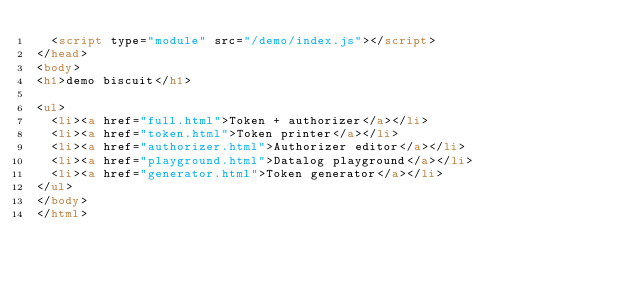Convert code to text. <code><loc_0><loc_0><loc_500><loc_500><_HTML_>  <script type="module" src="/demo/index.js"></script>
</head>
<body>
<h1>demo biscuit</h1>

<ul>
  <li><a href="full.html">Token + authorizer</a></li>
  <li><a href="token.html">Token printer</a></li>
  <li><a href="authorizer.html">Authorizer editor</a></li>
  <li><a href="playground.html">Datalog playground</a></li>
  <li><a href="generator.html">Token generator</a></li>
</ul>
</body>
</html>
</code> 